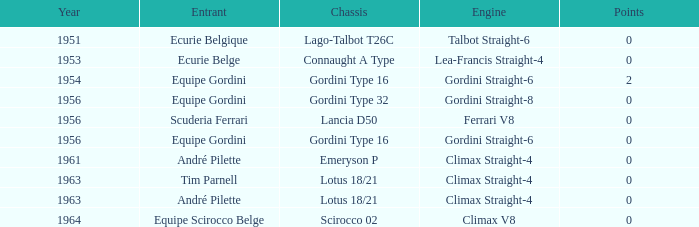Who was in 1963? Tim Parnell, André Pilette. 